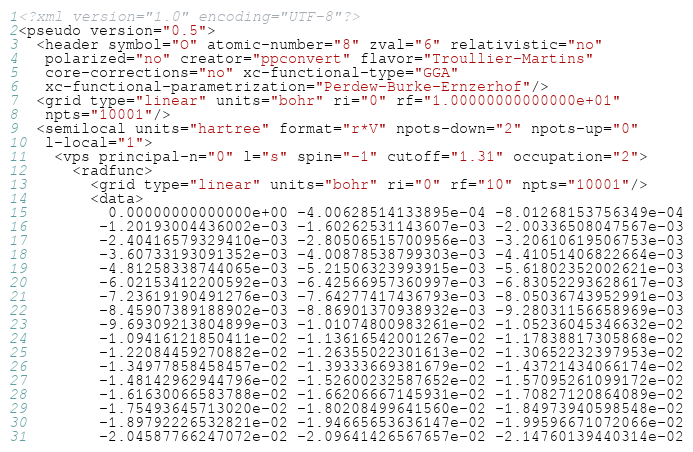<code> <loc_0><loc_0><loc_500><loc_500><_XML_><?xml version="1.0" encoding="UTF-8"?>
<pseudo version="0.5">
  <header symbol="O" atomic-number="8" zval="6" relativistic="no" 
   polarized="no" creator="ppconvert" flavor="Troullier-Martins" 
   core-corrections="no" xc-functional-type="GGA" 
   xc-functional-parametrization="Perdew-Burke-Ernzerhof"/>
  <grid type="linear" units="bohr" ri="0" rf="1.00000000000000e+01" 
   npts="10001"/>
  <semilocal units="hartree" format="r*V" npots-down="2" npots-up="0" 
   l-local="1">
    <vps principal-n="0" l="s" spin="-1" cutoff="1.31" occupation="2">
      <radfunc>
        <grid type="linear" units="bohr" ri="0" rf="10" npts="10001"/>
        <data>
          0.00000000000000e+00 -4.00628514133895e-04 -8.01268153756349e-04
         -1.20193004436002e-03 -1.60262531143607e-03 -2.00336508047567e-03
         -2.40416579329410e-03 -2.80506515700956e-03 -3.20610619506753e-03
         -3.60733193091352e-03 -4.00878538799303e-03 -4.41051406822664e-03
         -4.81258338744065e-03 -5.21506323993915e-03 -5.61802352002621e-03
         -6.02153412200592e-03 -6.42566957360997e-03 -6.83052293628617e-03
         -7.23619190491276e-03 -7.64277417436793e-03 -8.05036743952991e-03
         -8.45907389188902e-03 -8.86901370938932e-03 -9.28031156658969e-03
         -9.69309213804899e-03 -1.01074800983261e-02 -1.05236045346632e-02
         -1.09416121850411e-02 -1.13616542001267e-02 -1.17838817305868e-02
         -1.22084459270882e-02 -1.26355022301613e-02 -1.30652232397953e-02
         -1.34977858458457e-02 -1.39333669381679e-02 -1.43721434066174e-02
         -1.48142962944796e-02 -1.52600232587652e-02 -1.57095261099172e-02
         -1.61630066583788e-02 -1.66206667145931e-02 -1.70827120864089e-02
         -1.75493645713020e-02 -1.80208499641560e-02 -1.84973940598548e-02
         -1.89792226532821e-02 -1.94665653636147e-02 -1.99596671072066e-02
         -2.04587766247072e-02 -2.09641426567657e-02 -2.14760139440314e-02</code> 